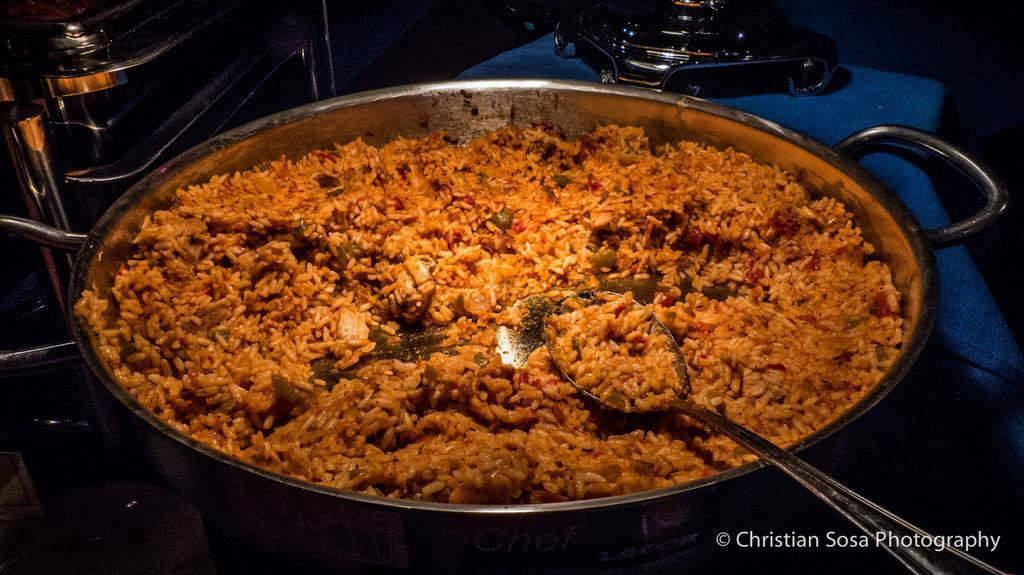Please provide a concise description of this image. This image is taken indoors. In the middle of the image there is a utensil with rice and a spoon in it. In the background there are a few utensils. 